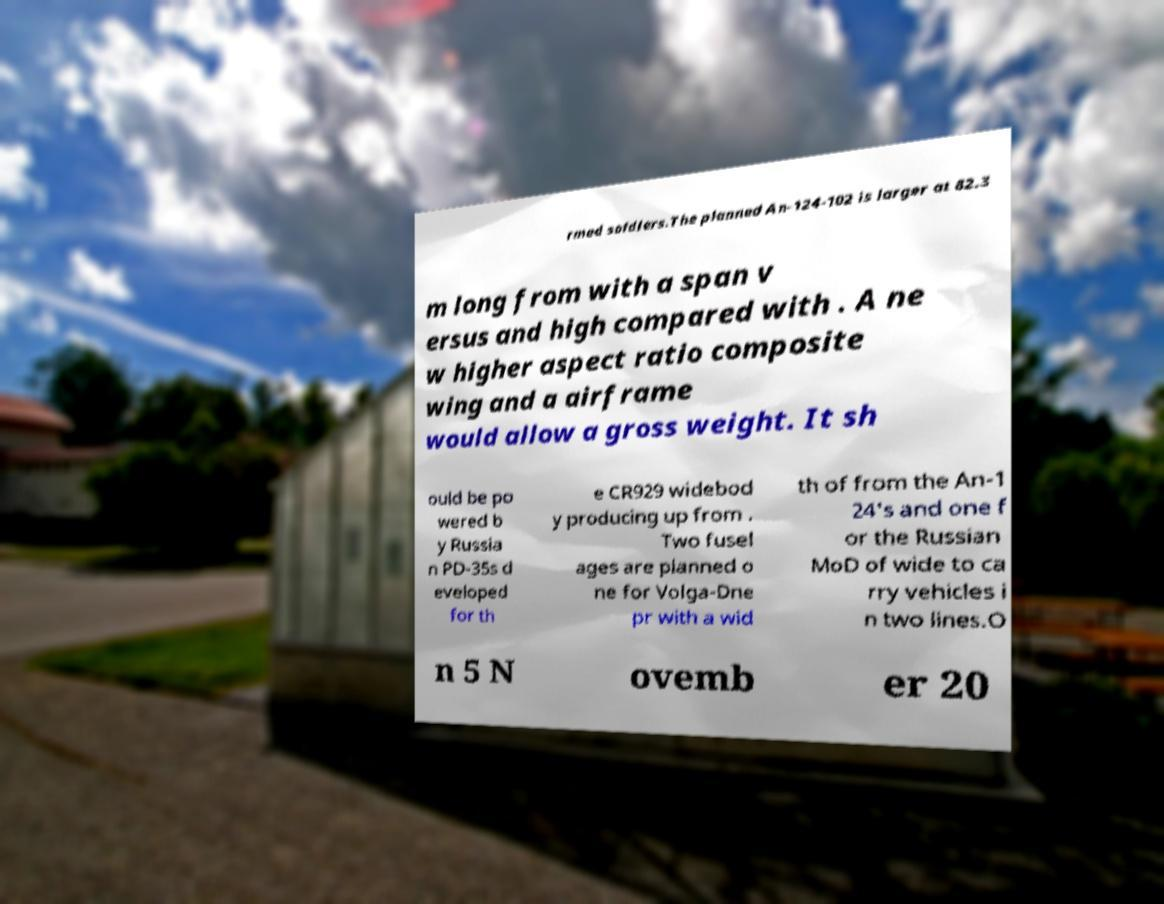Could you assist in decoding the text presented in this image and type it out clearly? rmed soldiers.The planned An-124-102 is larger at 82.3 m long from with a span v ersus and high compared with . A ne w higher aspect ratio composite wing and a airframe would allow a gross weight. It sh ould be po wered b y Russia n PD-35s d eveloped for th e CR929 widebod y producing up from . Two fusel ages are planned o ne for Volga-Dne pr with a wid th of from the An-1 24's and one f or the Russian MoD of wide to ca rry vehicles i n two lines.O n 5 N ovemb er 20 